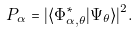<formula> <loc_0><loc_0><loc_500><loc_500>P _ { \alpha } = | \langle \Phi ^ { * } _ { \alpha , \theta } | \Psi _ { \theta } \rangle | ^ { 2 } .</formula> 